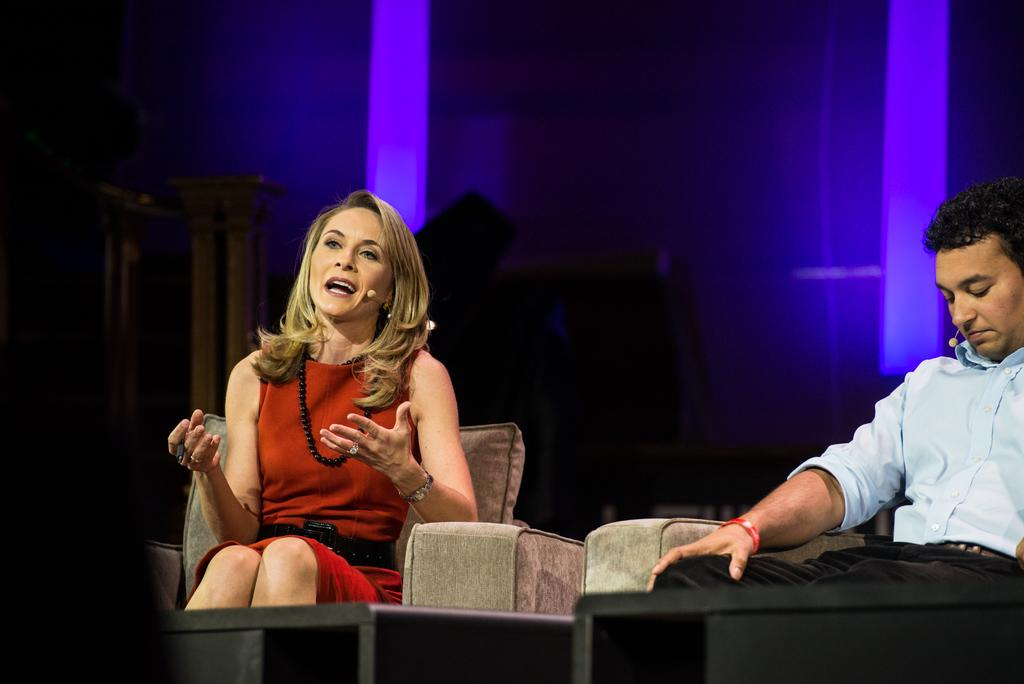How many people are in the image? There are two people in the image. What are the people doing in the image? The people are sitting on sofas. Can you describe the woman's action in the image? The woman is speaking. What can be seen in the image that provides illumination? There are lights visible in the image. What else can be seen in the background of the image? There are other settings in the background. What type of wind can be seen blowing through the trees in the image? There are no trees or wind present in the image; it features two people sitting on sofas with a woman speaking. 